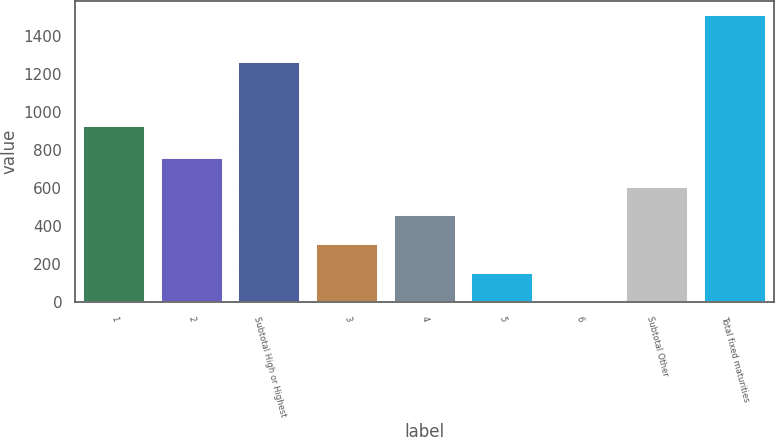Convert chart to OTSL. <chart><loc_0><loc_0><loc_500><loc_500><bar_chart><fcel>1<fcel>2<fcel>Subtotal High or Highest<fcel>3<fcel>4<fcel>5<fcel>6<fcel>Subtotal Other<fcel>Total fixed maturities<nl><fcel>925<fcel>756.5<fcel>1260<fcel>306.2<fcel>456.3<fcel>156.1<fcel>6<fcel>606.4<fcel>1507<nl></chart> 